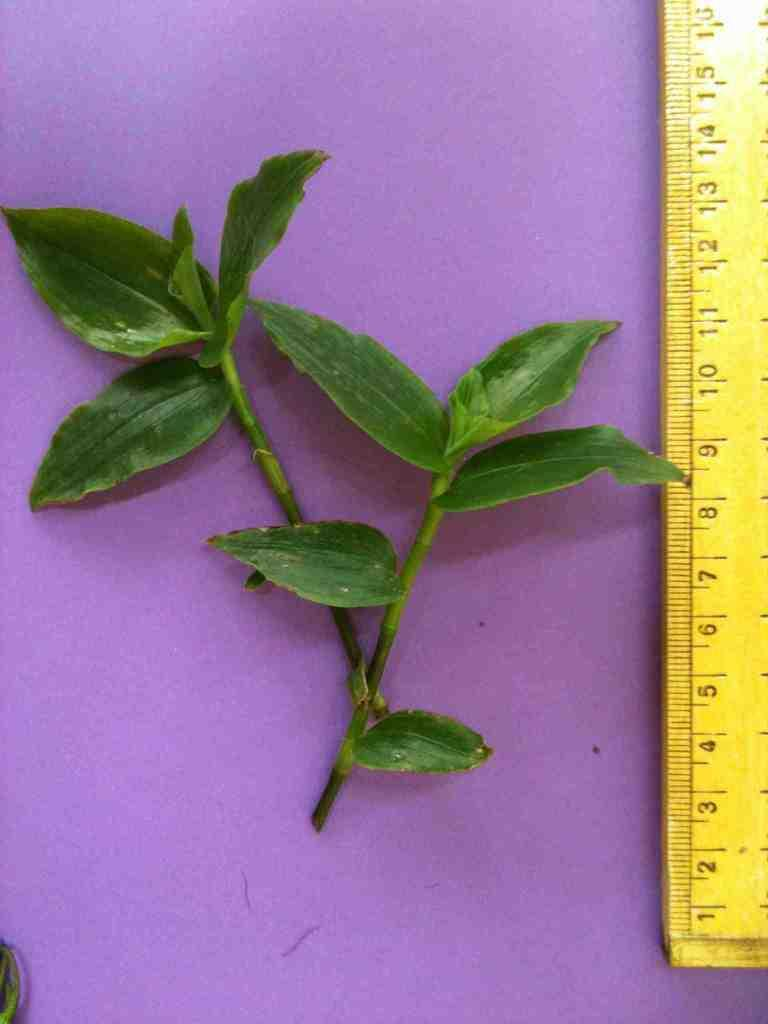Provide a one-sentence caption for the provided image. A ruler beside a plant measuring about twelve centimeters. 